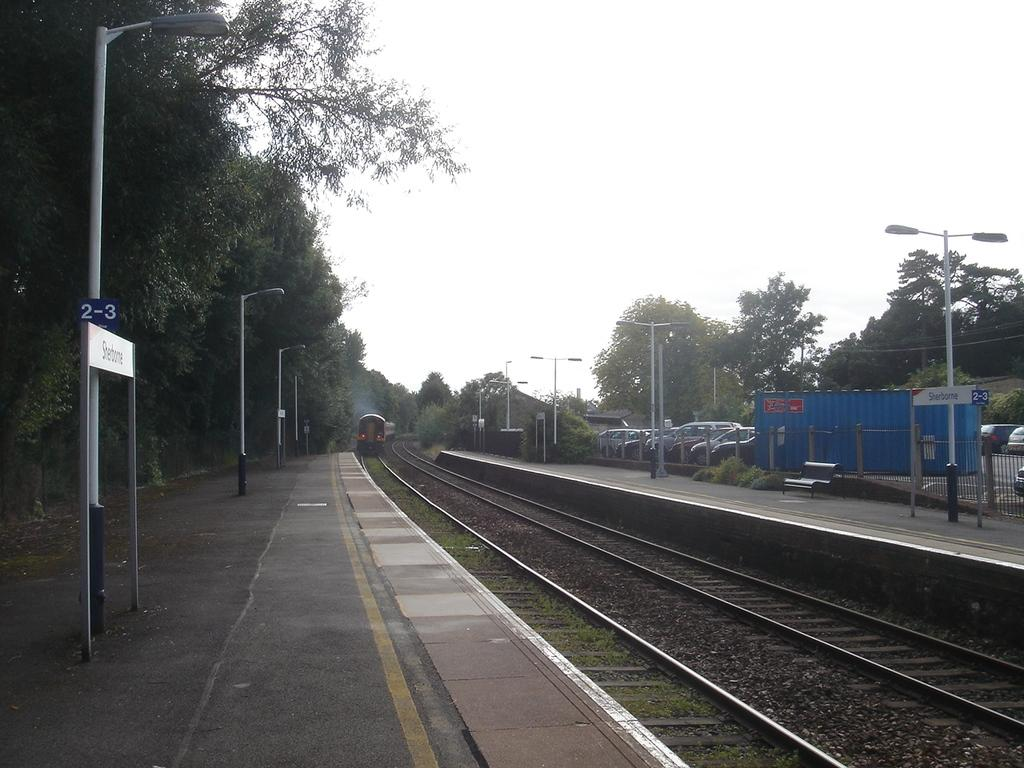What is the main subject of the image? The main subject of the image is a railway track. What is happening on the railway track? A train is moving on the railway track. What can be seen in the background of the image? There are trees visible in the image. What else is present in the image besides the railway track and train? Electric poles are present in the image. How many mice are playing with a kite on the railway track in the image? There are no mice or kites present in the image; it features a railway track and a moving train. What is the annual income of the person who owns the train in the image? The image does not provide any information about the owner of the train or their income. 